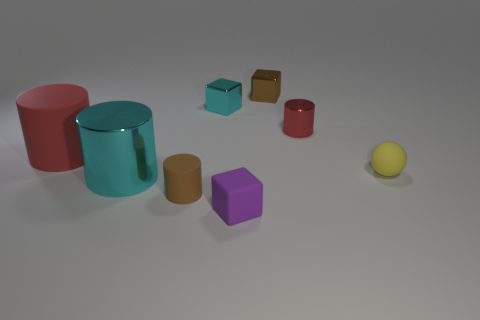Subtract all tiny metal cubes. How many cubes are left? 1 Subtract all gray balls. How many red cylinders are left? 2 Add 2 brown metallic objects. How many objects exist? 10 Subtract 1 cylinders. How many cylinders are left? 3 Subtract all purple cubes. How many cubes are left? 2 Subtract all blocks. How many objects are left? 5 Subtract all purple cylinders. Subtract all gray spheres. How many cylinders are left? 4 Add 1 rubber cubes. How many rubber cubes are left? 2 Add 8 small brown metal things. How many small brown metal things exist? 9 Subtract 0 blue cylinders. How many objects are left? 8 